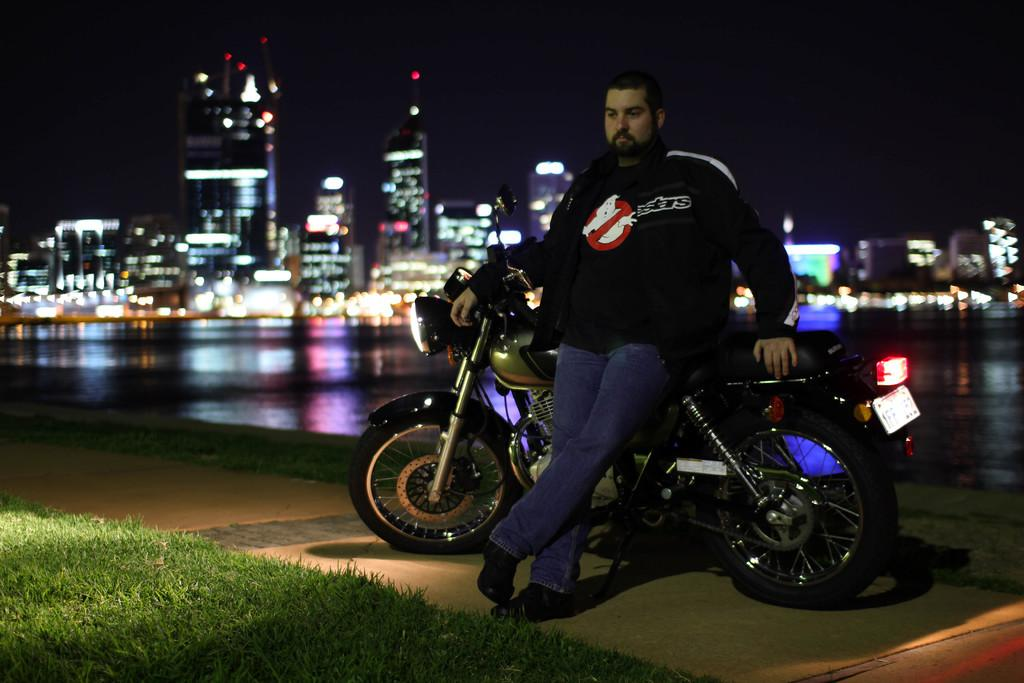Who or what is present in the image? There is a person in the image. What object is also visible in the image? There is a bike in the image. What can be seen in the distance in the image? There are buildings and lights in the background of the image. What is visible at the bottom of the image? There is water and ground visible at the bottom of the image. What type of waves can be seen in the image? There are no waves visible in the image; it features a person, a bike, buildings, lights, water, and ground. How does the person in the image feel about the situation? The image does not provide any information about the person's feelings or emotions. 